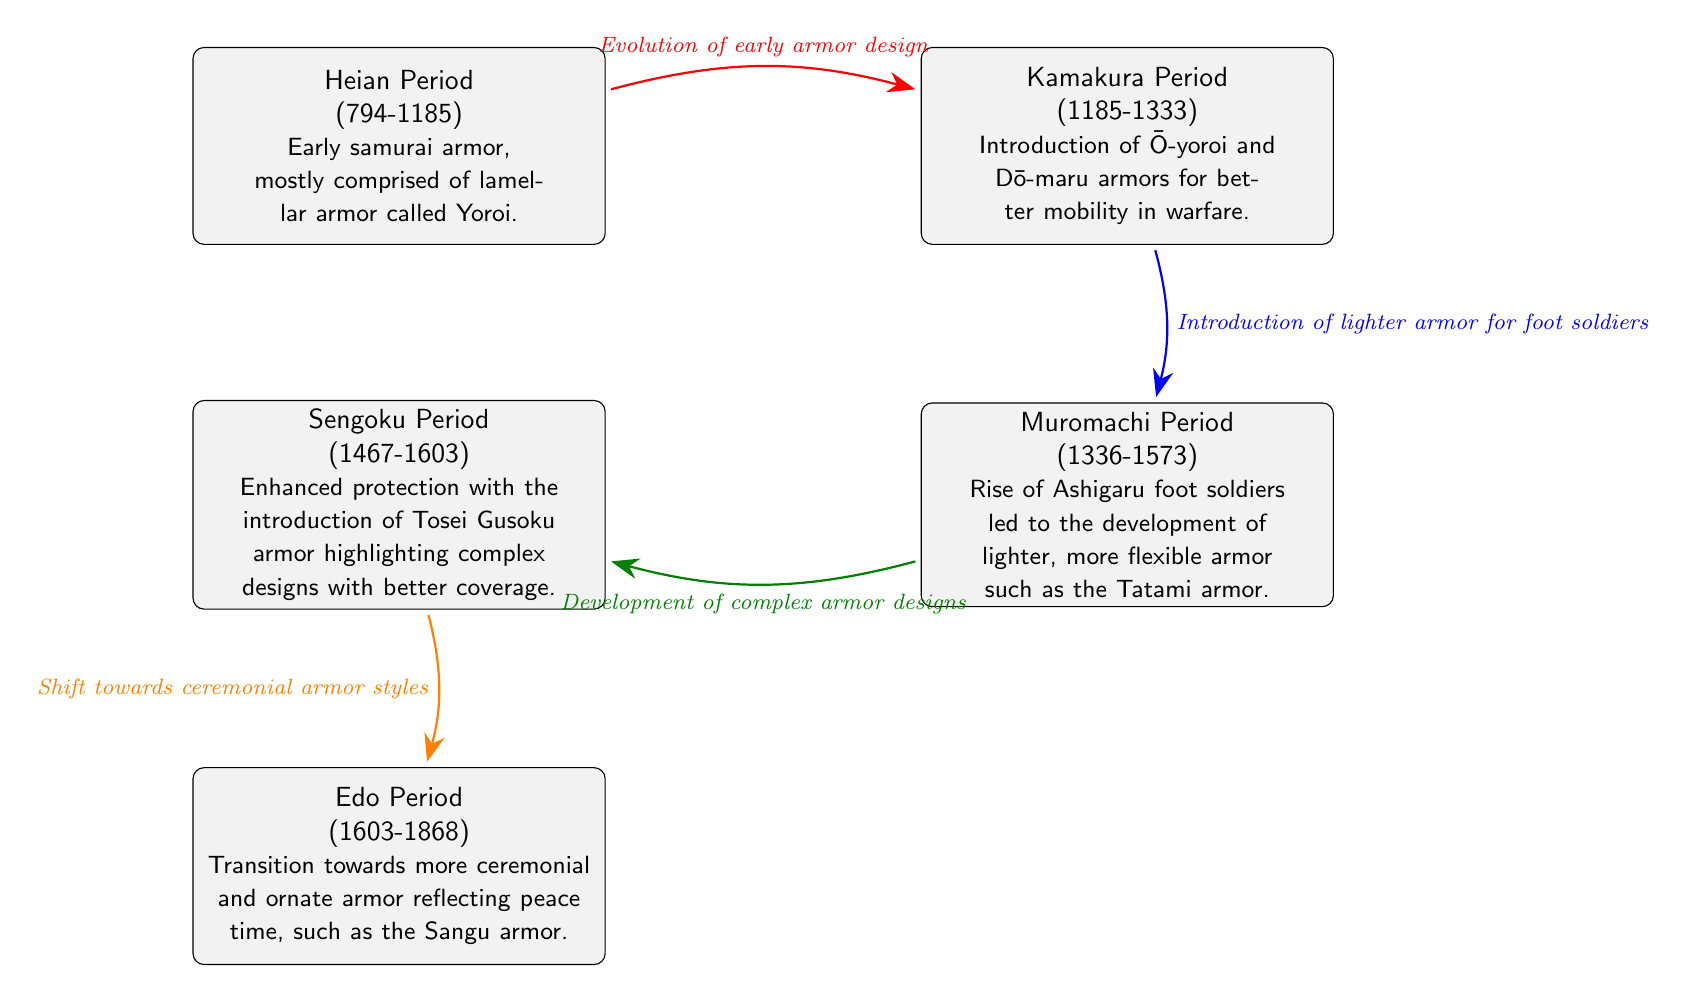What is the first period of samurai armor evolution shown in the diagram? The first node in the diagram represents the Heian Period, indicating that it is the starting point of the samurai armor evolution timeline.
Answer: Heian Period How many periods of samurai armor evolution are represented in the diagram? By counting the nodes displayed in the diagram, there are a total of five distinct periods illustrating the evolution of samurai armor.
Answer: 5 What type of armor was introduced in the Kamakura Period? The description for the Kamakura Period node specifies the introduction of Ō-yoroi and Dō-maru armors, which are the specific types of armor mentioned.
Answer: Ō-yoroi and Dō-maru Which period saw the development of lighter armor for foot soldiers? The arrow leading from the Kamakura Period to the Muromachi Period indicates the introduction of lighter armor for foot soldiers, directly connecting these two periods.
Answer: Muromachi Period What indicates the transition to ceremonial armor styles? The arrow from the Sengoku Period to the Edo Period labeled "Shift towards ceremonial armor styles" highlights that this transition is a defining aspect of the Edo Period.
Answer: Edo Period What is the main characteristic of armor in the Sengoku Period? The Sengoku Period is described as having enhanced protection with Tosei Gusoku armor, which is a critical characteristic of that period.
Answer: Enhanced protection In which period do we see the introduction of complex armor designs? The transition from the Muromachi Period to the Sengoku Period features the development of complex armor designs, as indicated by the directed arrow showing this relationship.
Answer: Sengoku Period What type of armor reflects a peaceful time in the Edo Period? The description for the Edo Period specifies that the Sangu armor reflects the ceremonial and ornate nature of this period, distinguishing it from earlier styles.
Answer: Sangu armor Which relationship illustrates the evolution of early armor design? The arrow connecting the Heian Period to the Kamakura Period directly highlights the evolution of early armor design, as denoted by the label on the arrow.
Answer: Evolution of early armor design 